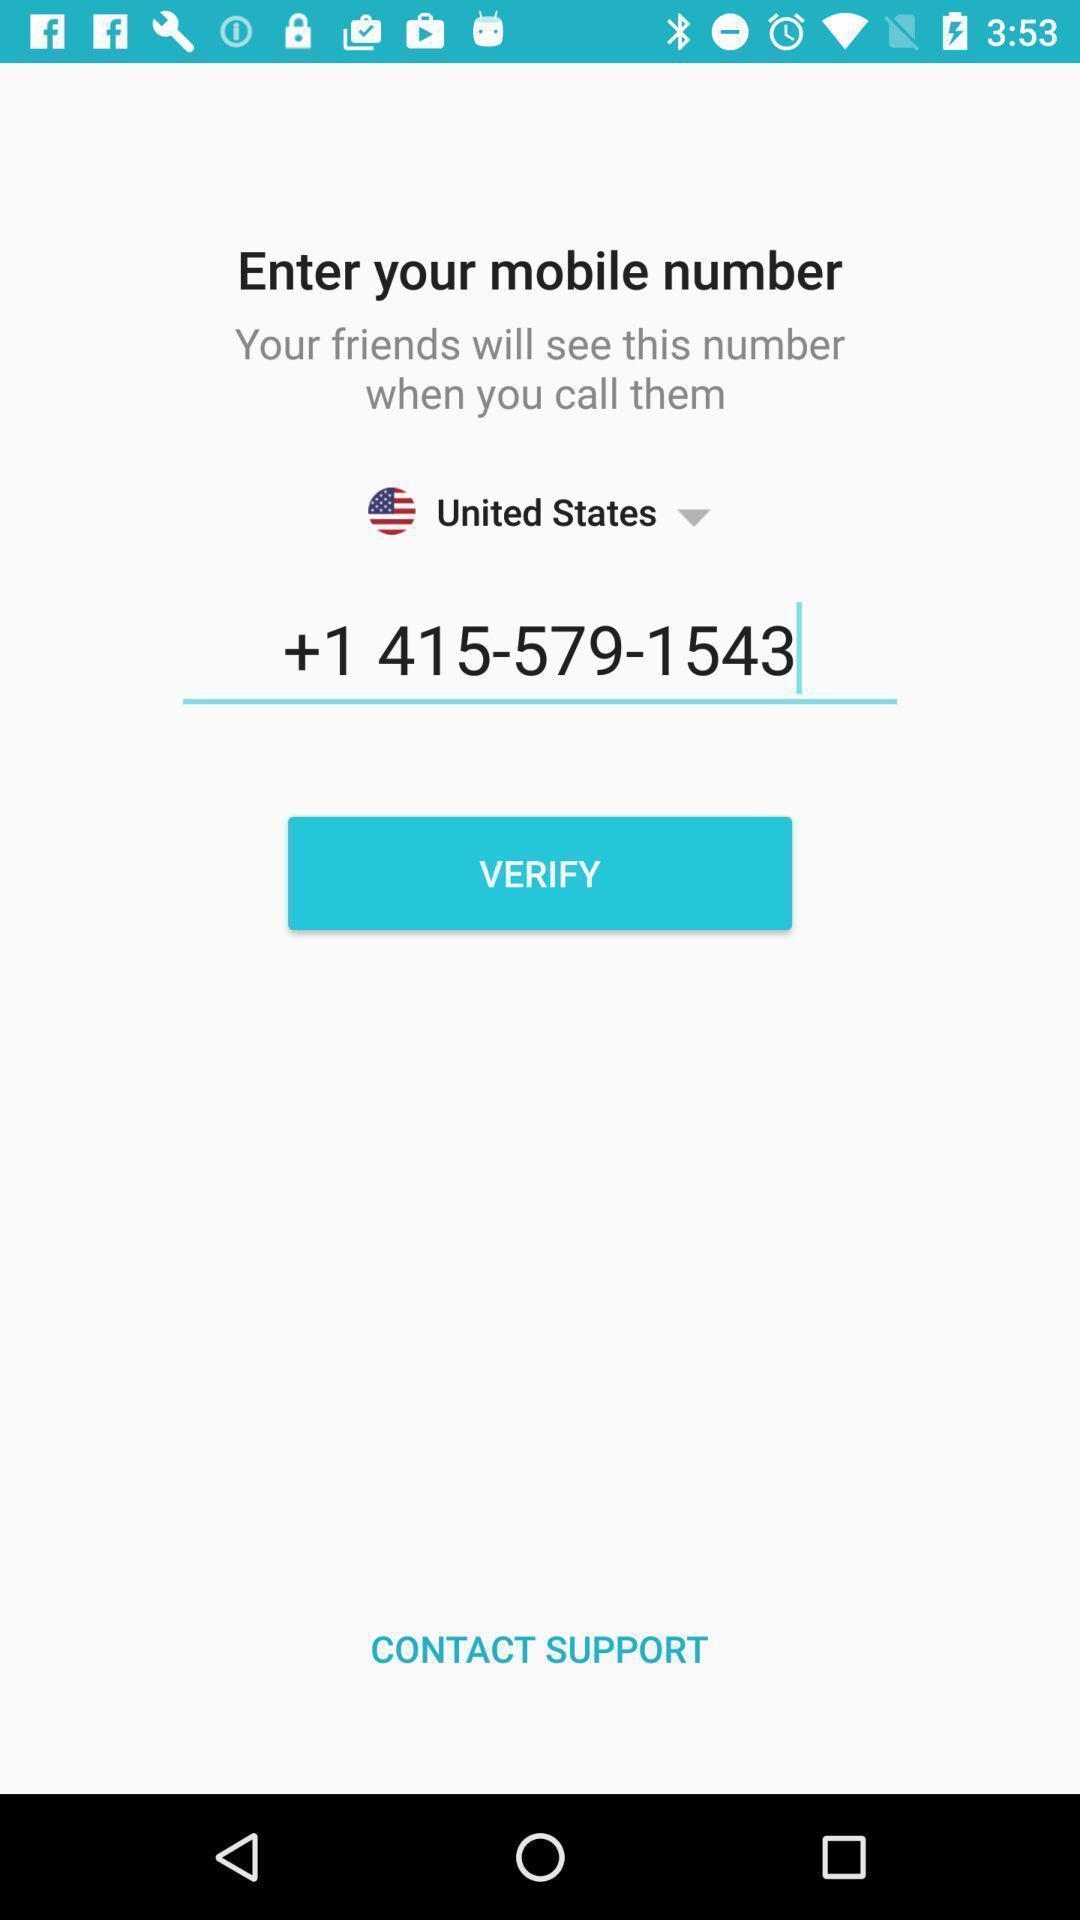Summarize the information in this screenshot. Screen shows verification details in a calls app. 